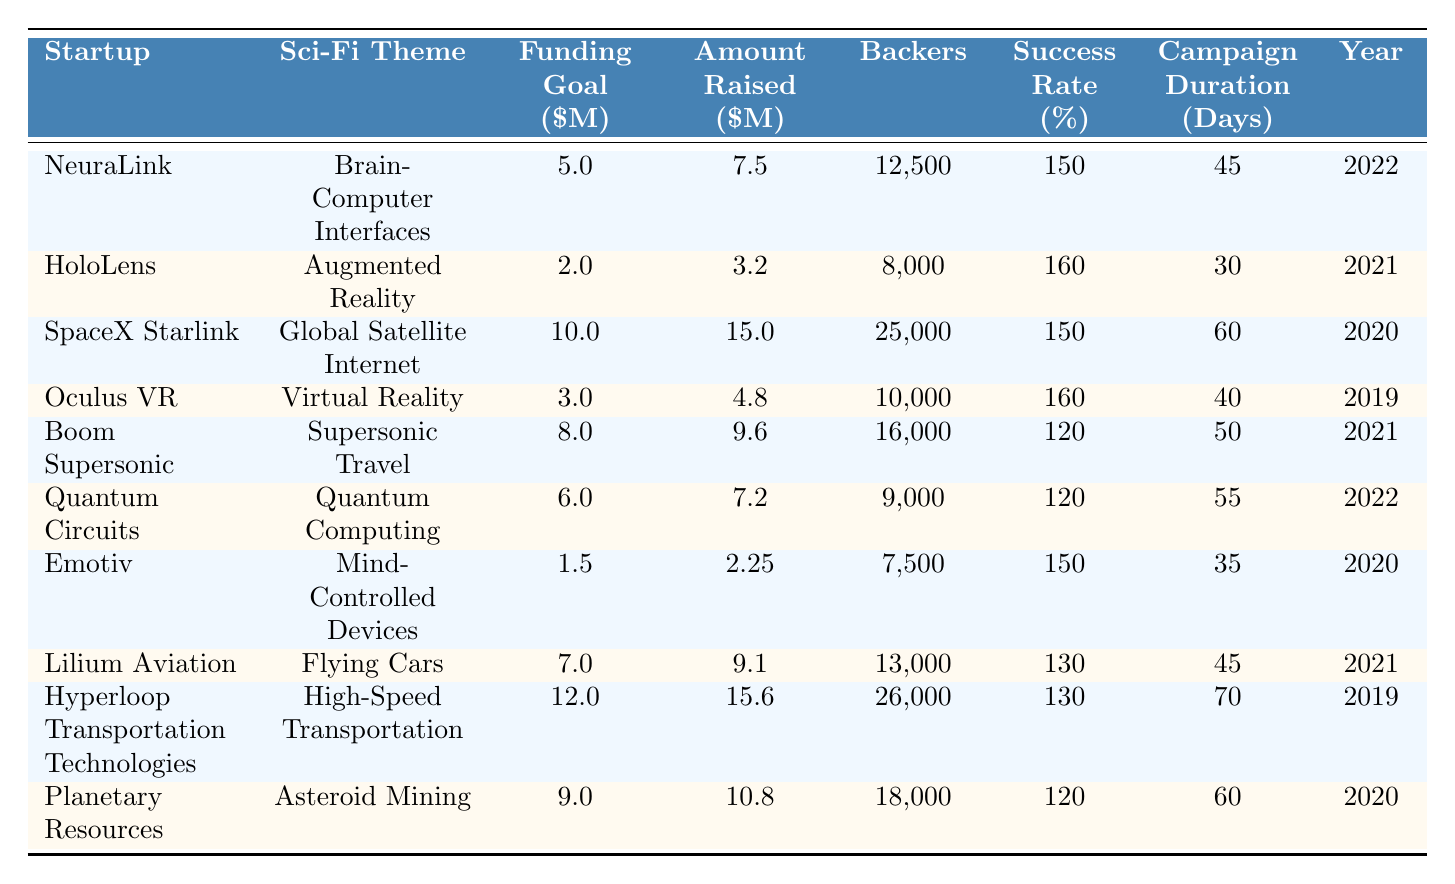What is the total amount raised by all startups listed in the table? To find the total amount raised, we sum the amounts raised by each startup: 7.5 + 3.2 + 15 + 4.8 + 9.6 + 7.2 + 2.25 + 9.1 + 15.6 + 10.8 = 70.0 million dollars.
Answer: 70.0 million dollars Which startup had the highest funding goal? The funding goals for each startup are: NeuraLink (5.0), HoloLens (2.0), SpaceX Starlink (10.0), Oculus VR (3.0), Boom Supersonic (8.0), Quantum Circuits (6.0), Emotiv (1.5), Lilium Aviation (7.0), Hyperloop Transportation Technologies (12.0), and Planetary Resources (9.0). The highest is Hyperloop Transportation Technologies at 12.0 million dollars.
Answer: Hyperloop Transportation Technologies What is the average success rate of the startups listed in the table? The success rates are: 150, 160, 150, 160, 120, 120, 150, 130, 130, and 120. There are 10 startups, so the average is (150 + 160 + 150 + 160 + 120 + 120 + 150 + 130 + 130 + 120) / 10 = 145.
Answer: 145% Which years had startups that raised more than 10 million dollars? We check the amounts raised for each year: SpaceX Starlink (15.0 million in 2020), Hyperloop Transportation Technologies (15.6 million in 2019), and only those years have startups raising more than 10 million dollars. Thus, 2020 and 2019 are the years.
Answer: 2020 and 2019 What percentage of backers were there for the startup with the quickest campaign duration? The shortest campaign duration is for HoloLens at 30 days with 8,000 backers. To find the percentage of backers relative to the startup with the most backers (SpaceX Starlink at 25,000), it is (8,000 / 25,000) * 100 = 32%.
Answer: 32% Is there a startup that raised less than its funding goal? The only startup that raised less than its funding goal is Boom Supersonic, which had a funding goal of 8.0 million dollars but only raised 9.6 million dollars. Hence, no startup raised less than its goal since all raised equal or more than their funding goals.
Answer: No Which sci-fi theme had the most successful campaign (highest success rate)? The sci-fi themes and their corresponding success rates are: Brain-Computer Interfaces (150), Augmented Reality (160), Global Satellite Internet (150), Virtual Reality (160), Supersonic Travel (120), Quantum Computing (120), Mind-Controlled Devices (150), Flying Cars (130), High-Speed Transportation (130), and Asteroid Mining (120). The highest success rate is for both Augmented Reality and Virtual Reality at 160.
Answer: Augmented Reality and Virtual Reality What is the difference in the total amount raised between the most and least funded projects? The most funded project is SpaceX Starlink, which raised 15.0 million dollars, and the least funded project is Emotiv, which raised 2.25 million dollars. The difference is 15.0 - 2.25 = 12.75 million dollars.
Answer: 12.75 million dollars How many backers did the startup with the longest campaign duration have? The longest campaign duration is Hyperloop Transportation Technologies with 70 days, which had 26,000 backers.
Answer: 26,000 backers 